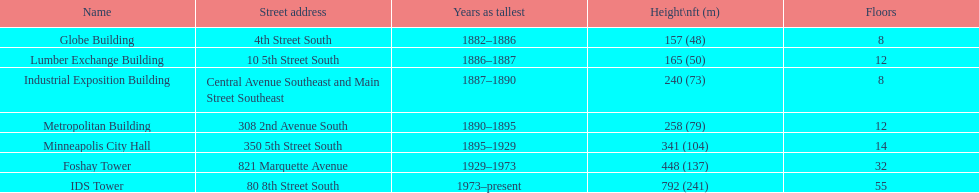Name the tallest building. IDS Tower. 